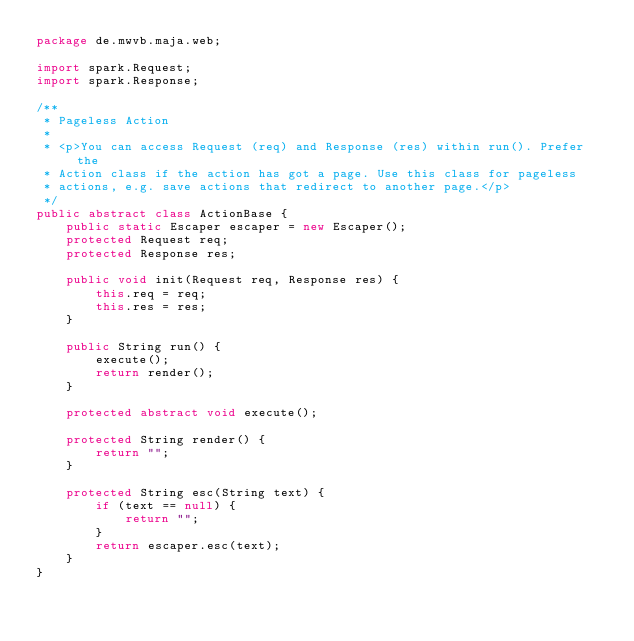<code> <loc_0><loc_0><loc_500><loc_500><_Java_>package de.mwvb.maja.web;

import spark.Request;
import spark.Response;

/**
 * Pageless Action
 * 
 * <p>You can access Request (req) and Response (res) within run(). Prefer the
 * Action class if the action has got a page. Use this class for pageless
 * actions, e.g. save actions that redirect to another page.</p>
 */
public abstract class ActionBase {
    public static Escaper escaper = new Escaper();
    protected Request req;
    protected Response res;

    public void init(Request req, Response res) {
        this.req = req;
        this.res = res;
    }

    public String run() {
        execute();
        return render();
    }

    protected abstract void execute();

    protected String render() {
        return "";
    }

    protected String esc(String text) {
        if (text == null) {
            return "";
        }
        return escaper.esc(text);
    }
}
</code> 